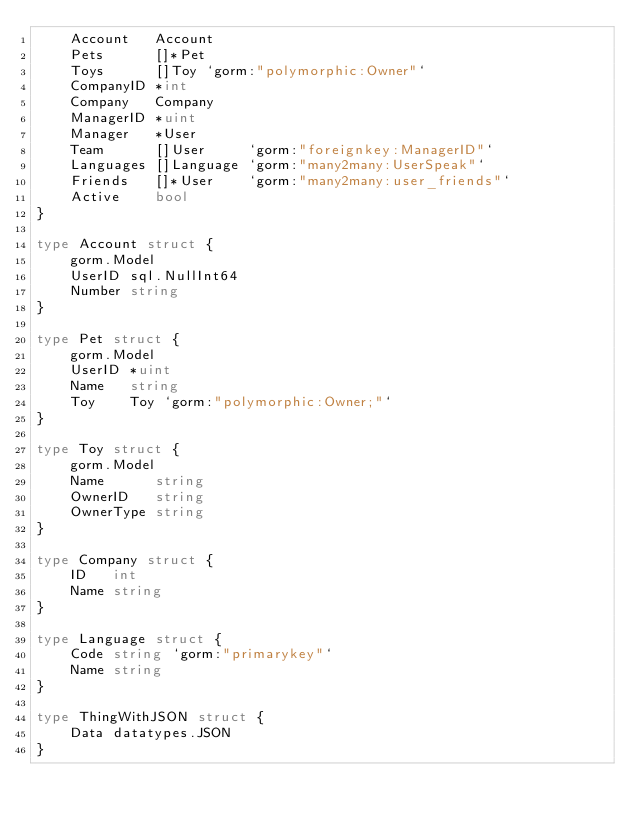Convert code to text. <code><loc_0><loc_0><loc_500><loc_500><_Go_>	Account   Account
	Pets      []*Pet
	Toys      []Toy `gorm:"polymorphic:Owner"`
	CompanyID *int
	Company   Company
	ManagerID *uint
	Manager   *User
	Team      []User     `gorm:"foreignkey:ManagerID"`
	Languages []Language `gorm:"many2many:UserSpeak"`
	Friends   []*User    `gorm:"many2many:user_friends"`
	Active    bool
}

type Account struct {
	gorm.Model
	UserID sql.NullInt64
	Number string
}

type Pet struct {
	gorm.Model
	UserID *uint
	Name   string
	Toy    Toy `gorm:"polymorphic:Owner;"`
}

type Toy struct {
	gorm.Model
	Name      string
	OwnerID   string
	OwnerType string
}

type Company struct {
	ID   int
	Name string
}

type Language struct {
	Code string `gorm:"primarykey"`
	Name string
}

type ThingWithJSON struct {
	Data datatypes.JSON
}
</code> 